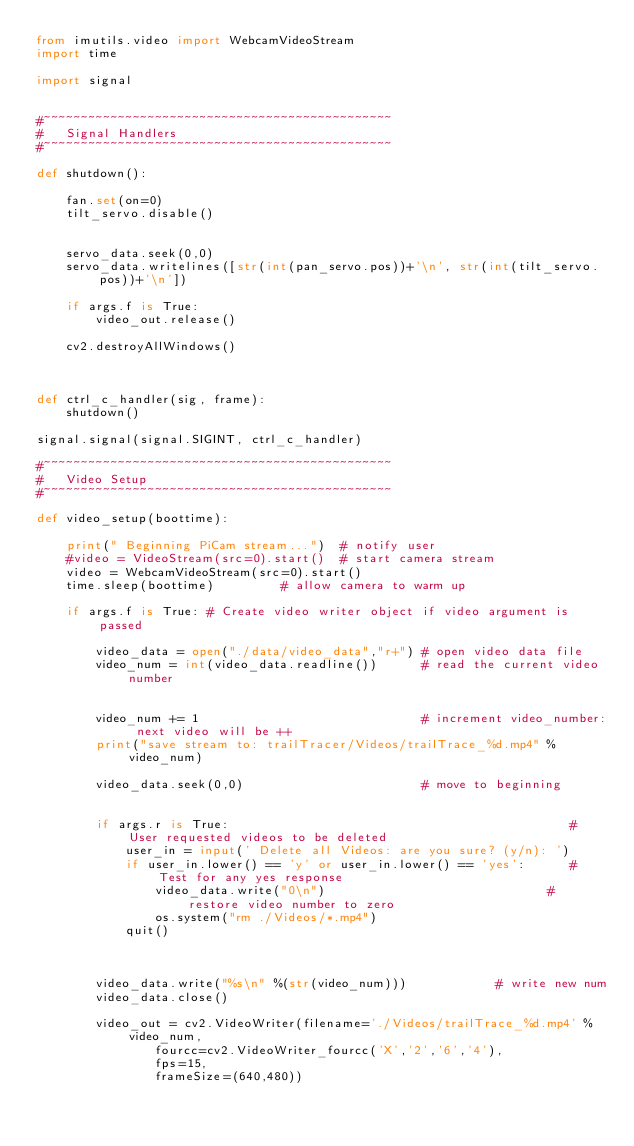Convert code to text. <code><loc_0><loc_0><loc_500><loc_500><_Python_>from imutils.video import WebcamVideoStream
import time

import signal


#~~~~~~~~~~~~~~~~~~~~~~~~~~~~~~~~~~~~~~~~~~~~~~~
#   Signal Handlers
#~~~~~~~~~~~~~~~~~~~~~~~~~~~~~~~~~~~~~~~~~~~~~~~

def shutdown():
    
    fan.set(on=0)
    tilt_servo.disable()


    servo_data.seek(0,0)
    servo_data.writelines([str(int(pan_servo.pos))+'\n', str(int(tilt_servo.pos))+'\n'])

    if args.f is True:
        video_out.release()

    cv2.destroyAllWindows()



def ctrl_c_handler(sig, frame):
    shutdown()
    
signal.signal(signal.SIGINT, ctrl_c_handler)

#~~~~~~~~~~~~~~~~~~~~~~~~~~~~~~~~~~~~~~~~~~~~~~~
#   Video Setup
#~~~~~~~~~~~~~~~~~~~~~~~~~~~~~~~~~~~~~~~~~~~~~~~

def video_setup(boottime):

    print(" Beginning PiCam stream...")  # notify user
    #video = VideoStream(src=0).start()  # start camera stream
    video = WebcamVideoStream(src=0).start()
    time.sleep(boottime)         # allow camera to warm up

    if args.f is True: # Create video writer object if video argument is passed

        video_data = open("./data/video_data","r+") # open video data file
        video_num = int(video_data.readline())      # read the current video number


        video_num += 1                              # increment video_number: next video will be ++
        print("save stream to: trailTracer/Videos/trailTrace_%d.mp4" % video_num)

        video_data.seek(0,0)                        # move to beginning

        
        if args.r is True:                                              # User requested videos to be deleted
            user_in = input(' Delete all Videos: are you sure? (y/n): ')
            if user_in.lower() == 'y' or user_in.lower() == 'yes':      # Test for any yes response
                video_data.write("0\n")                              # restore video number to zero   
                os.system("rm ./Videos/*.mp4")
            quit()

        

        video_data.write("%s\n" %(str(video_num)))            # write new num
        video_data.close()

        video_out = cv2.VideoWriter(filename='./Videos/trailTrace_%d.mp4' % video_num, 
                fourcc=cv2.VideoWriter_fourcc('X','2','6','4'), 
                fps=15, 
                frameSize=(640,480))





</code> 